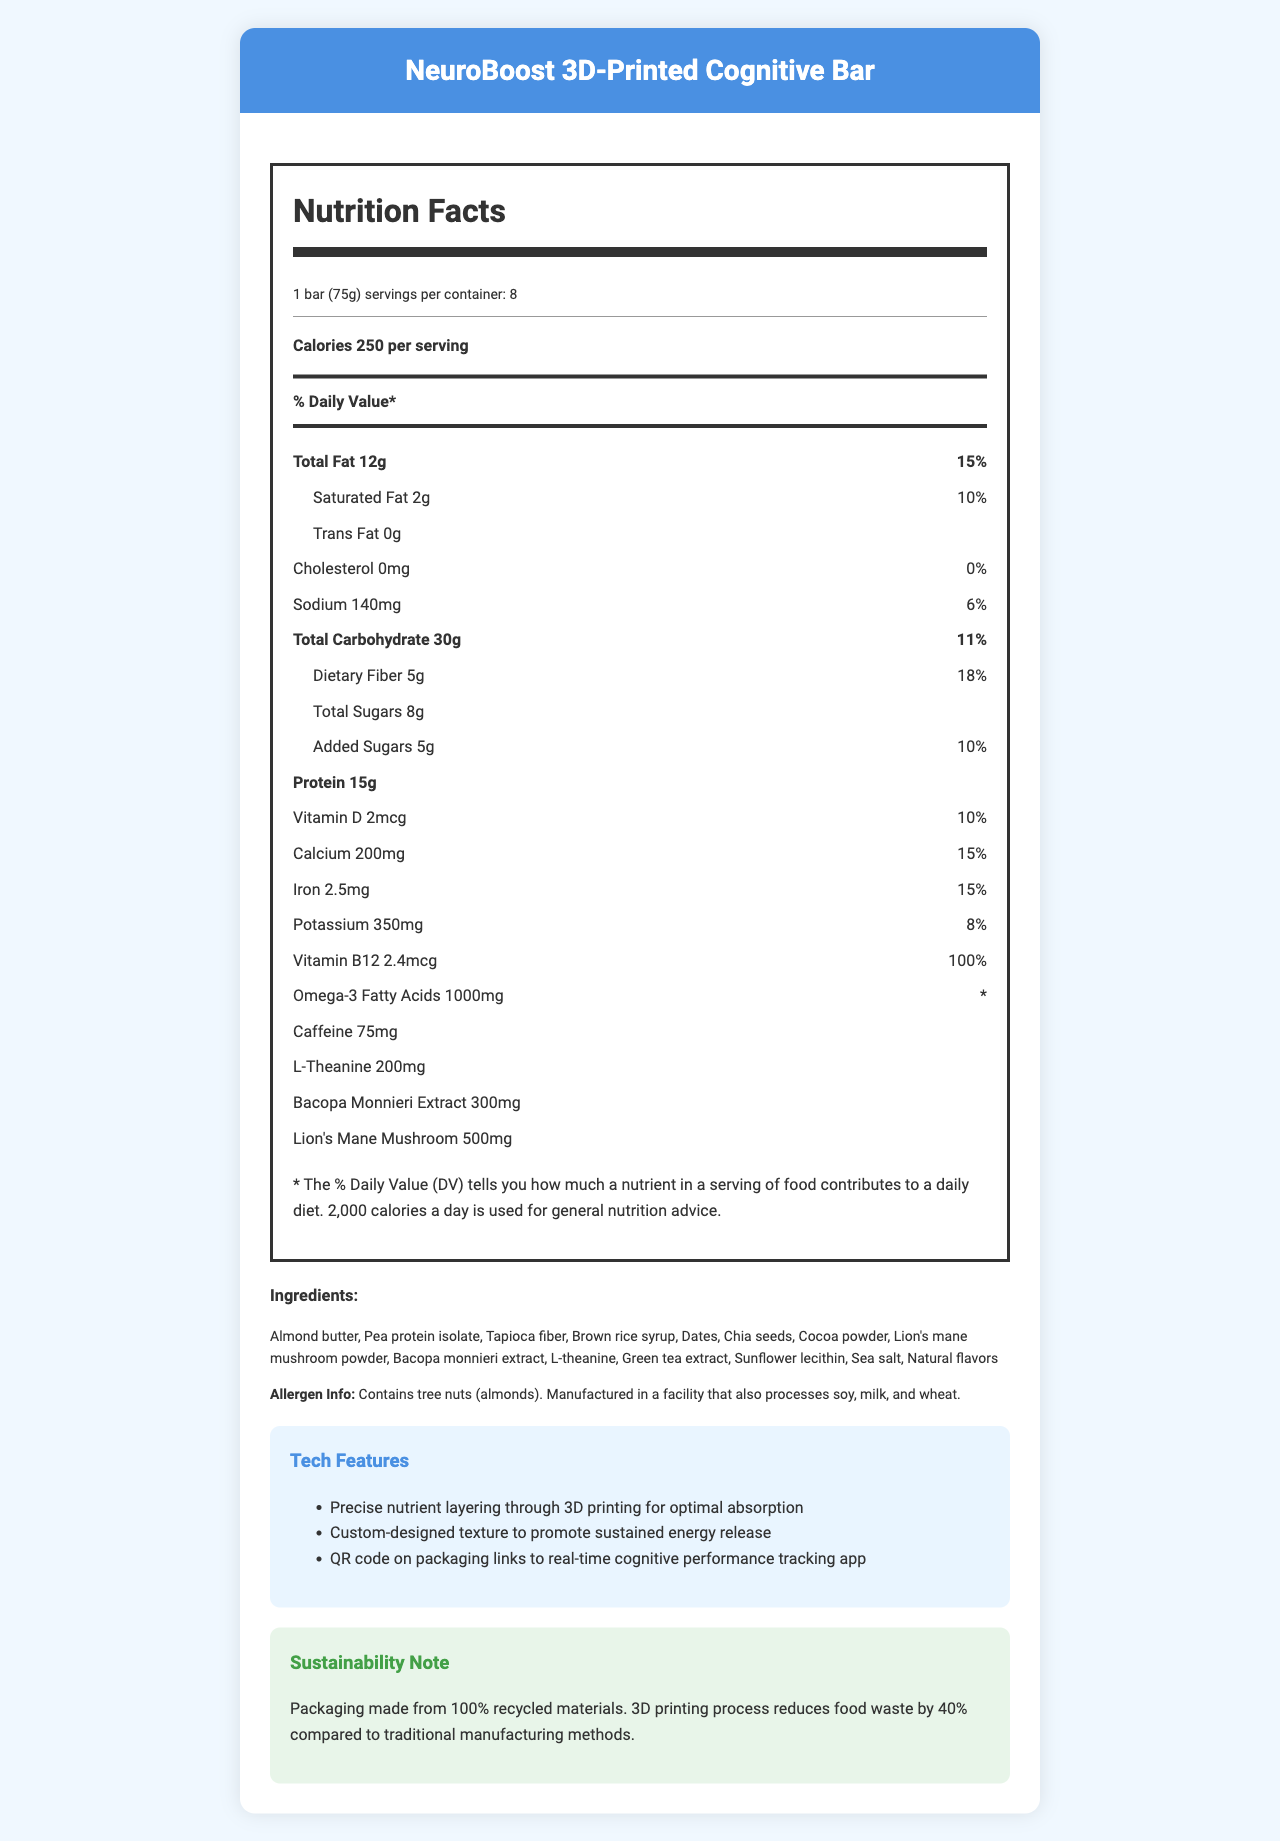what is the serving size of the NeuroBoost 3D-Printed Cognitive Bar? The serving size is listed at the beginning of the Nutrition Facts section as "1 bar (75g)".
Answer: 1 bar (75g) how many servings are there per container? The document states this in the serving information line as "servings per container: 8".
Answer: 8 what is the total fat content per serving? The total fat content is listed in the Nutrition Facts section as "Total Fat 12g".
Answer: 12g how much protein does each bar contain? The protein content is listed as "Protein 15g" in the Nutrition Facts section.
Answer: 15g how much caffeine is in the bar? The caffeine content is listed as "Caffeine 75mg" in the document.
Answer: 75mg which ingredient is used as a binder in the NeuroBoost bar? A. Almond butter B. Brown rice syrup C. Dates D. All of the above Ingredients used as binders such as almond butter, brown rice syrup, and dates are all listed among the ingredients.
Answer: D. All of the above which additional cognitive-enhancing ingredients are included? A. Bacopa Monnieri Extract B. Lion's Mane Mushroom C. L-Theanine D. All of the above The document lists Bacopa Monnieri Extract, Lion's Mane Mushroom, and L-Theanine as included ingredients.
Answer: D. All of the above does the product contain trans fat? The document states "Trans Fat 0g" indicating that there is no trans fat in the product.
Answer: No is the bar suitable for someone allergic to tree nuts? The allergen warning states "Contains tree nuts (almonds)".
Answer: No please summarize the main features and nutritional information of the NeuroBoost 3D-Printed Cognitive Bar. The summary covers the key aspects such as the product's purpose, nutritional details, cognitive-enhancing ingredients, innovative manufacturing techniques, and sustainability features.
Answer: The NeuroBoost 3D-Printed Cognitive Bar is designed to enhance cognitive performance, especially for tech professionals and autonomous vehicle engineers. Each bar (75g) contains 250 calories, 15g of protein, and a range of nootropic ingredients like Bacopa Monnieri Extract and Lion's Mane Mushroom. It also includes vitamins and minerals such as Vitamin B12 and Omega-3 Fatty Acids. The bar is manufactured using 3D printing technology, ensuring precise nutrient layers for optimal absorption and reduced food waste. The packaging is made of 100% recycled materials. what percentage of daily value for dietary fiber is provided by one bar? The document states that the dietary fiber content is "5g" which translates to "18%" of the daily value.
Answer: 18% what is the source of omega-3 fatty acids in the bar? The specific source of omega-3 fatty acids is not listed in the document. Only the amount (1000mg) is provided.
Answer: Cannot be determined what is the tech feature of the NeuroBoost bar related to cognitive performance tracking? One of the tech features listed is "QR code on packaging links to real-time cognitive performance tracking app".
Answer: QR code on packaging links to real-time cognitive performance tracking app 